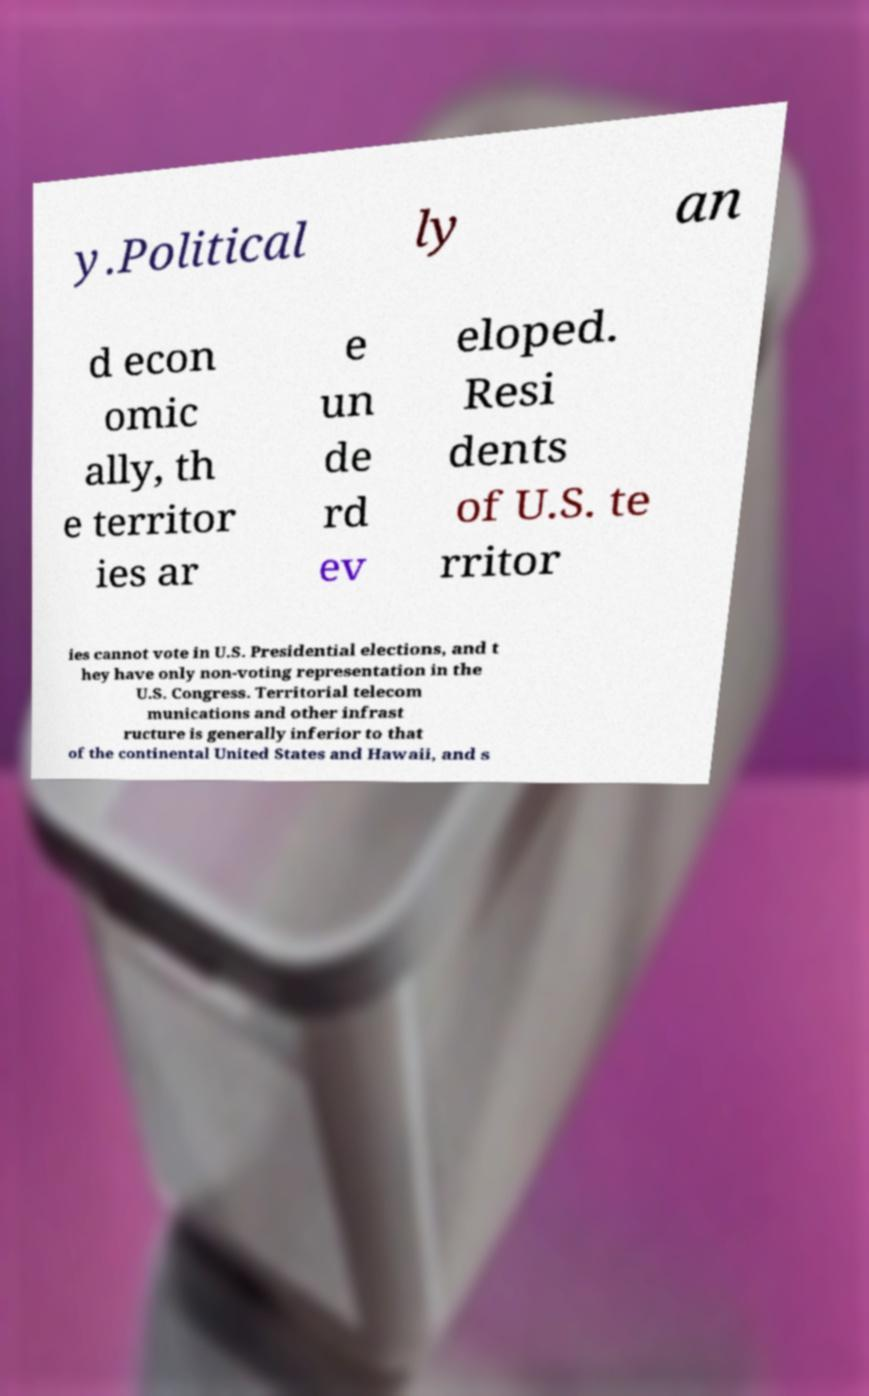What messages or text are displayed in this image? I need them in a readable, typed format. y.Political ly an d econ omic ally, th e territor ies ar e un de rd ev eloped. Resi dents of U.S. te rritor ies cannot vote in U.S. Presidential elections, and t hey have only non-voting representation in the U.S. Congress. Territorial telecom munications and other infrast ructure is generally inferior to that of the continental United States and Hawaii, and s 